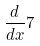<formula> <loc_0><loc_0><loc_500><loc_500>\frac { d } { d x } 7</formula> 